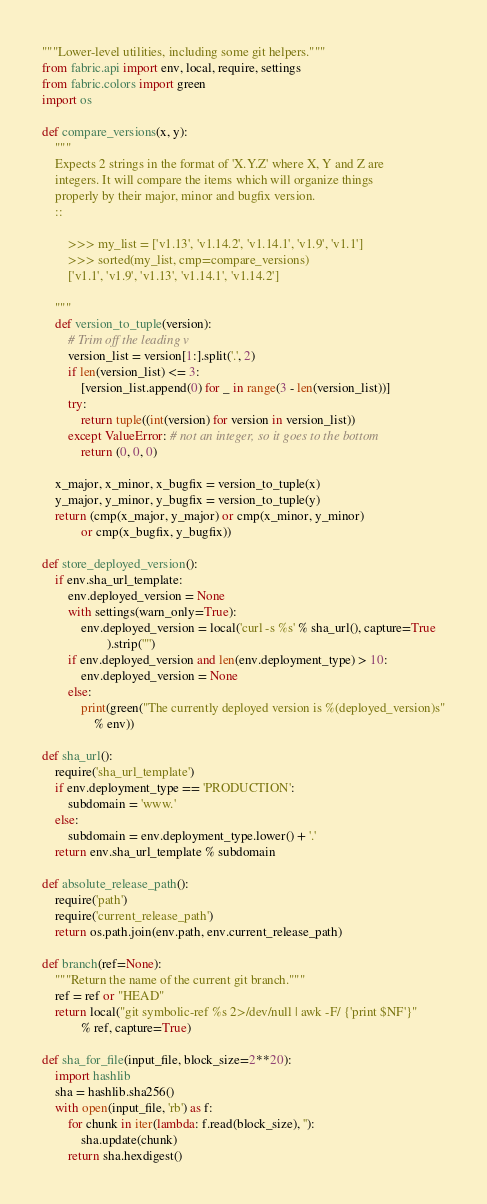Convert code to text. <code><loc_0><loc_0><loc_500><loc_500><_Python_>"""Lower-level utilities, including some git helpers."""
from fabric.api import env, local, require, settings
from fabric.colors import green
import os

def compare_versions(x, y):
    """
    Expects 2 strings in the format of 'X.Y.Z' where X, Y and Z are
    integers. It will compare the items which will organize things
    properly by their major, minor and bugfix version.
    ::

        >>> my_list = ['v1.13', 'v1.14.2', 'v1.14.1', 'v1.9', 'v1.1']
        >>> sorted(my_list, cmp=compare_versions)
        ['v1.1', 'v1.9', 'v1.13', 'v1.14.1', 'v1.14.2']

    """
    def version_to_tuple(version):
        # Trim off the leading v
        version_list = version[1:].split('.', 2)
        if len(version_list) <= 3:
            [version_list.append(0) for _ in range(3 - len(version_list))]
        try:
            return tuple((int(version) for version in version_list))
        except ValueError: # not an integer, so it goes to the bottom
            return (0, 0, 0)

    x_major, x_minor, x_bugfix = version_to_tuple(x)
    y_major, y_minor, y_bugfix = version_to_tuple(y)
    return (cmp(x_major, y_major) or cmp(x_minor, y_minor)
            or cmp(x_bugfix, y_bugfix))

def store_deployed_version():
    if env.sha_url_template:
        env.deployed_version = None
        with settings(warn_only=True):
            env.deployed_version = local('curl -s %s' % sha_url(), capture=True
                    ).strip('"')
        if env.deployed_version and len(env.deployment_type) > 10:
            env.deployed_version = None
        else:
            print(green("The currently deployed version is %(deployed_version)s"
                % env))

def sha_url():
    require('sha_url_template')
    if env.deployment_type == 'PRODUCTION':
        subdomain = 'www.'
    else:
        subdomain = env.deployment_type.lower() + '.'
    return env.sha_url_template % subdomain

def absolute_release_path():
    require('path')
    require('current_release_path')
    return os.path.join(env.path, env.current_release_path)

def branch(ref=None):
    """Return the name of the current git branch."""
    ref = ref or "HEAD"
    return local("git symbolic-ref %s 2>/dev/null | awk -F/ {'print $NF'}"
            % ref, capture=True)

def sha_for_file(input_file, block_size=2**20):
    import hashlib
    sha = hashlib.sha256()
    with open(input_file, 'rb') as f:
        for chunk in iter(lambda: f.read(block_size), ''):
            sha.update(chunk)
        return sha.hexdigest()
</code> 